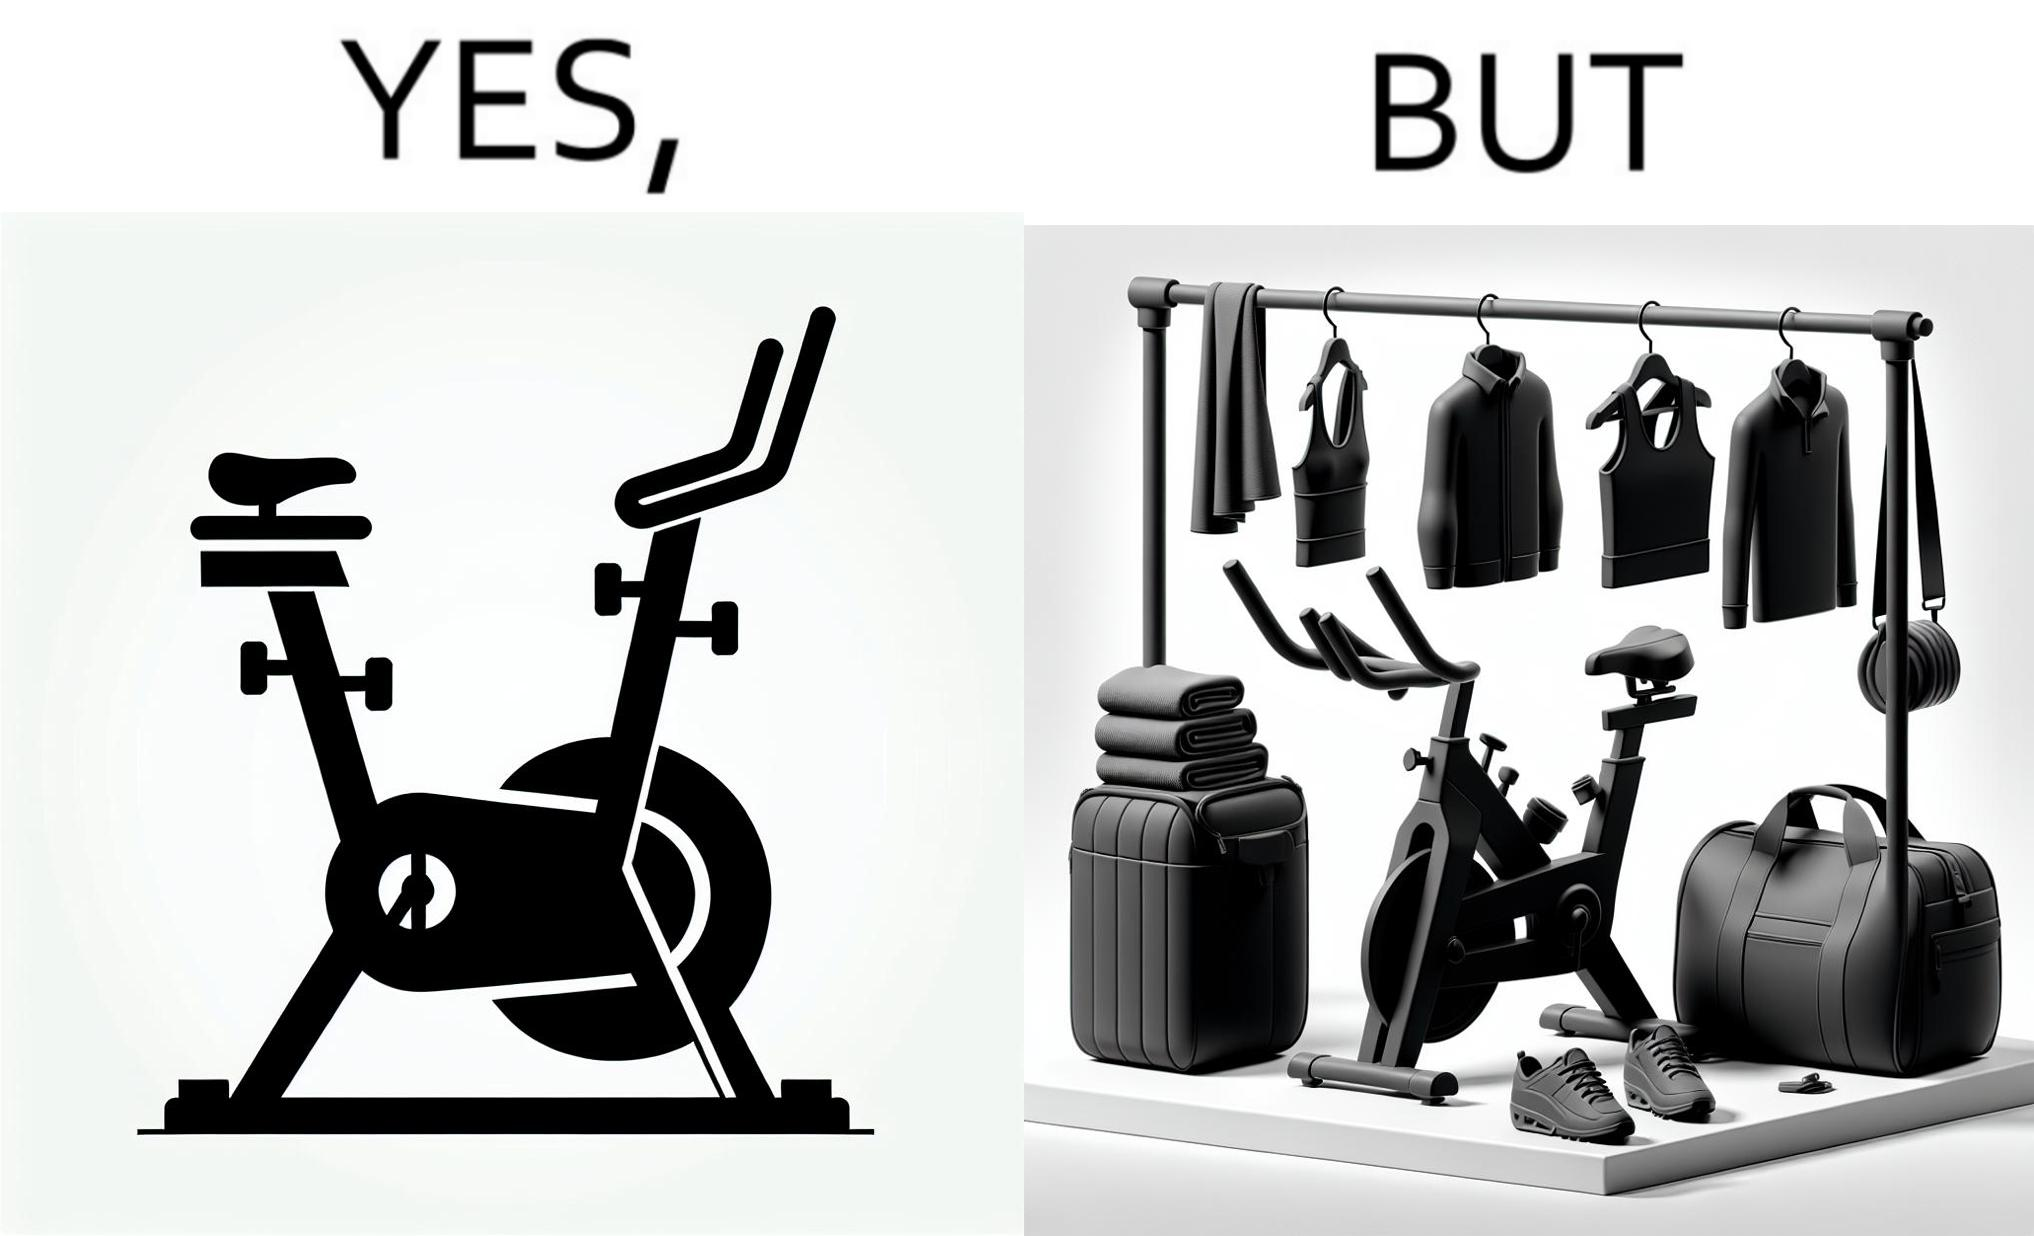What does this image depict? This is a satirical image with contrasting elements. 